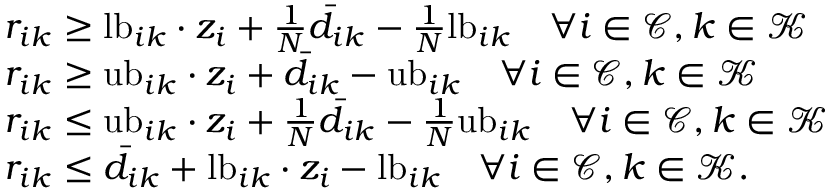Convert formula to latex. <formula><loc_0><loc_0><loc_500><loc_500>\begin{array} { r l } & { r _ { i k } \geq l b _ { i k } \cdot z _ { i } + \frac { 1 } { N } \bar { d } _ { i k } - \frac { 1 } { N } l b _ { i k } \quad \forall i \in \mathcal { C } , k \in \mathcal { K } } \\ & { r _ { i k } \geq u b _ { i k } \cdot z _ { i } + \bar { d } _ { i k } - u b _ { i k } \quad \forall i \in \mathcal { C } , k \in \mathcal { K } } \\ & { r _ { i k } \leq u b _ { i k } \cdot z _ { i } + \frac { 1 } { N } \bar { d } _ { i k } - \frac { 1 } { N } u b _ { i k } \quad \forall i \in \mathcal { C } , k \in \mathcal { K } } \\ & { r _ { i k } \leq \bar { d } _ { i k } + l b _ { i k } \cdot z _ { i } - l b _ { i k } \quad \forall i \in \mathcal { C } , k \in \mathcal { K } . } \end{array}</formula> 